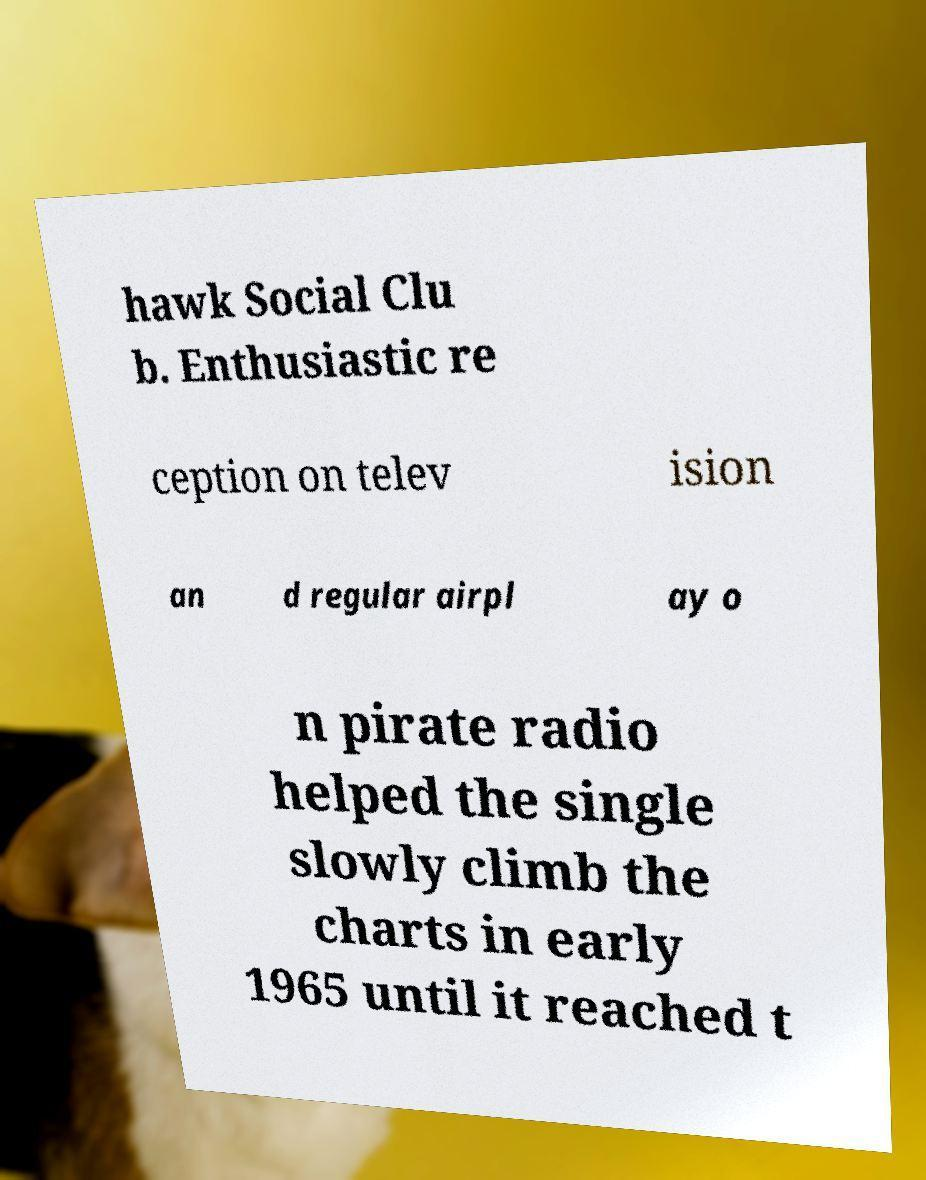Could you assist in decoding the text presented in this image and type it out clearly? hawk Social Clu b. Enthusiastic re ception on telev ision an d regular airpl ay o n pirate radio helped the single slowly climb the charts in early 1965 until it reached t 